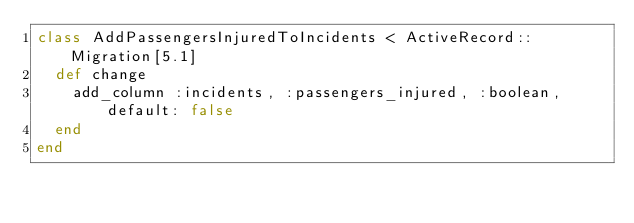<code> <loc_0><loc_0><loc_500><loc_500><_Ruby_>class AddPassengersInjuredToIncidents < ActiveRecord::Migration[5.1]
  def change
    add_column :incidents, :passengers_injured, :boolean, default: false
  end
end
</code> 